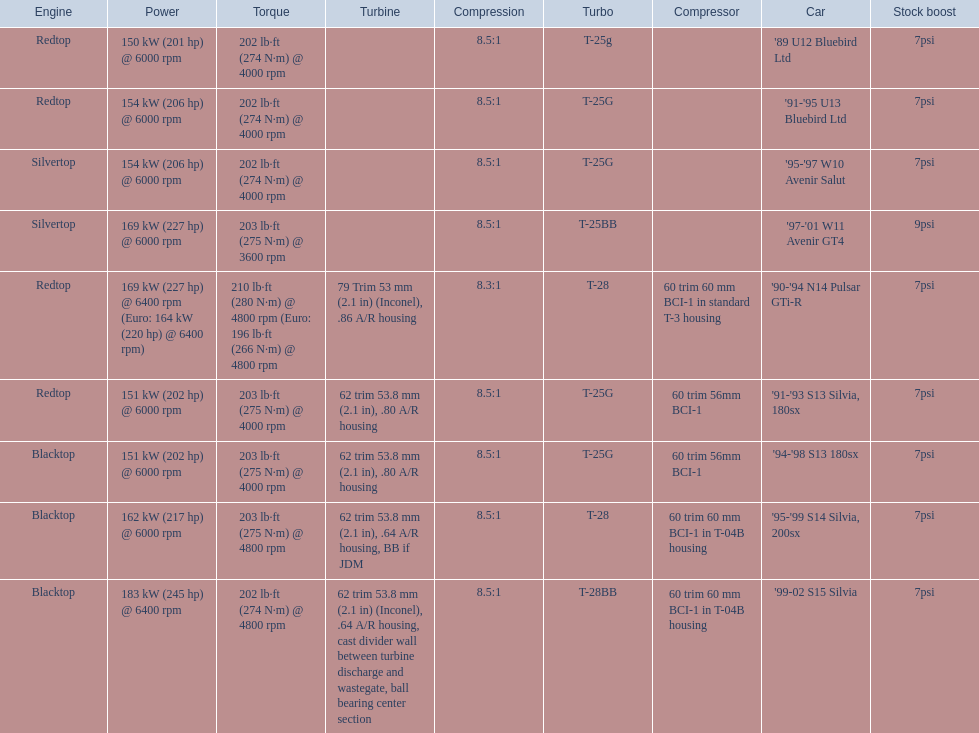Which cars list turbine details? '90-'94 N14 Pulsar GTi-R, '91-'93 S13 Silvia, 180sx, '94-'98 S13 180sx, '95-'99 S14 Silvia, 200sx, '99-02 S15 Silvia. Which of these hit their peak hp at the highest rpm? '90-'94 N14 Pulsar GTi-R, '99-02 S15 Silvia. Of those what is the compression of the only engine that isn't blacktop?? 8.3:1. 